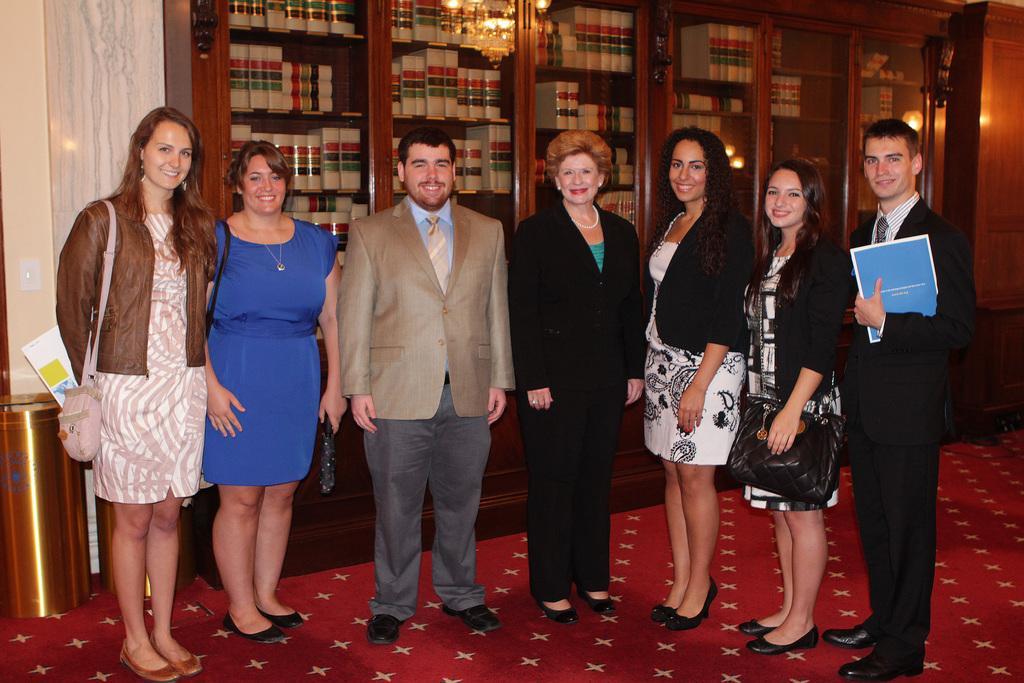How would you summarize this image in a sentence or two? In the picture we can see some people are standing on the red color carpet and they are smiling and in the background, we can see a wooden rack with glasses in it and in the racks we can see, full of books and beside it we can see a wall and on the floor we can see a dustbin. 